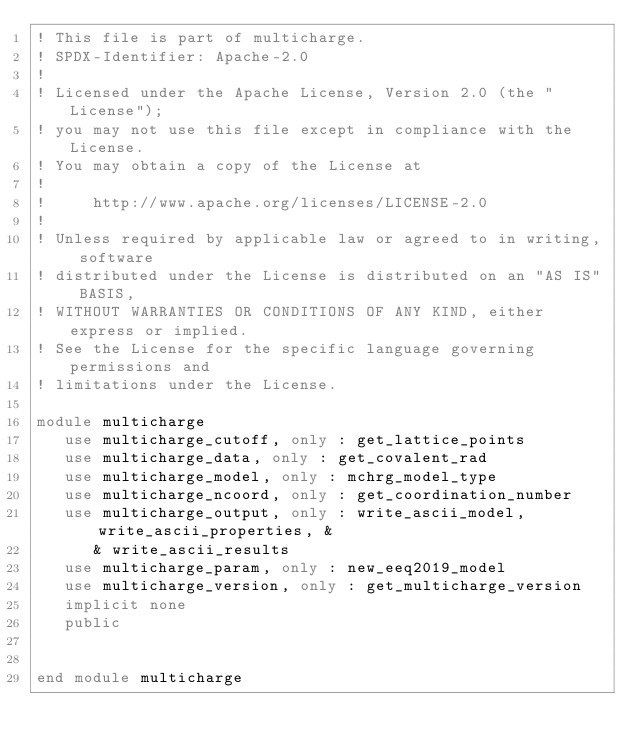Convert code to text. <code><loc_0><loc_0><loc_500><loc_500><_FORTRAN_>! This file is part of multicharge.
! SPDX-Identifier: Apache-2.0
!
! Licensed under the Apache License, Version 2.0 (the "License");
! you may not use this file except in compliance with the License.
! You may obtain a copy of the License at
!
!     http://www.apache.org/licenses/LICENSE-2.0
!
! Unless required by applicable law or agreed to in writing, software
! distributed under the License is distributed on an "AS IS" BASIS,
! WITHOUT WARRANTIES OR CONDITIONS OF ANY KIND, either express or implied.
! See the License for the specific language governing permissions and
! limitations under the License.

module multicharge
   use multicharge_cutoff, only : get_lattice_points
   use multicharge_data, only : get_covalent_rad
   use multicharge_model, only : mchrg_model_type
   use multicharge_ncoord, only : get_coordination_number
   use multicharge_output, only : write_ascii_model, write_ascii_properties, &
      & write_ascii_results
   use multicharge_param, only : new_eeq2019_model
   use multicharge_version, only : get_multicharge_version
   implicit none
   public


end module multicharge
</code> 